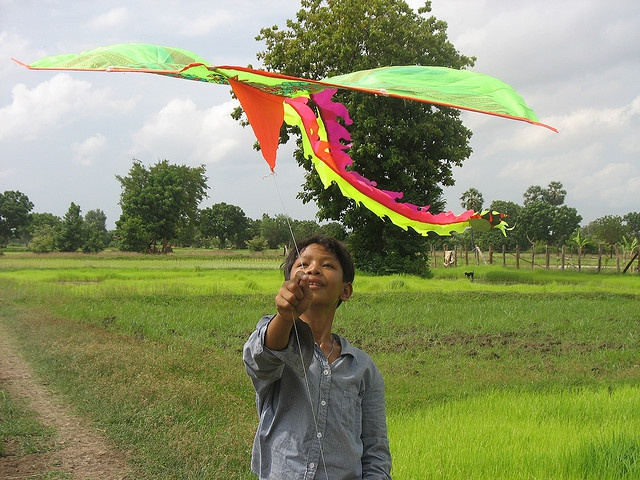Describe the objects in this image and their specific colors. I can see people in lavender, gray, black, and maroon tones and kite in lavender, lightgreen, red, and yellow tones in this image. 